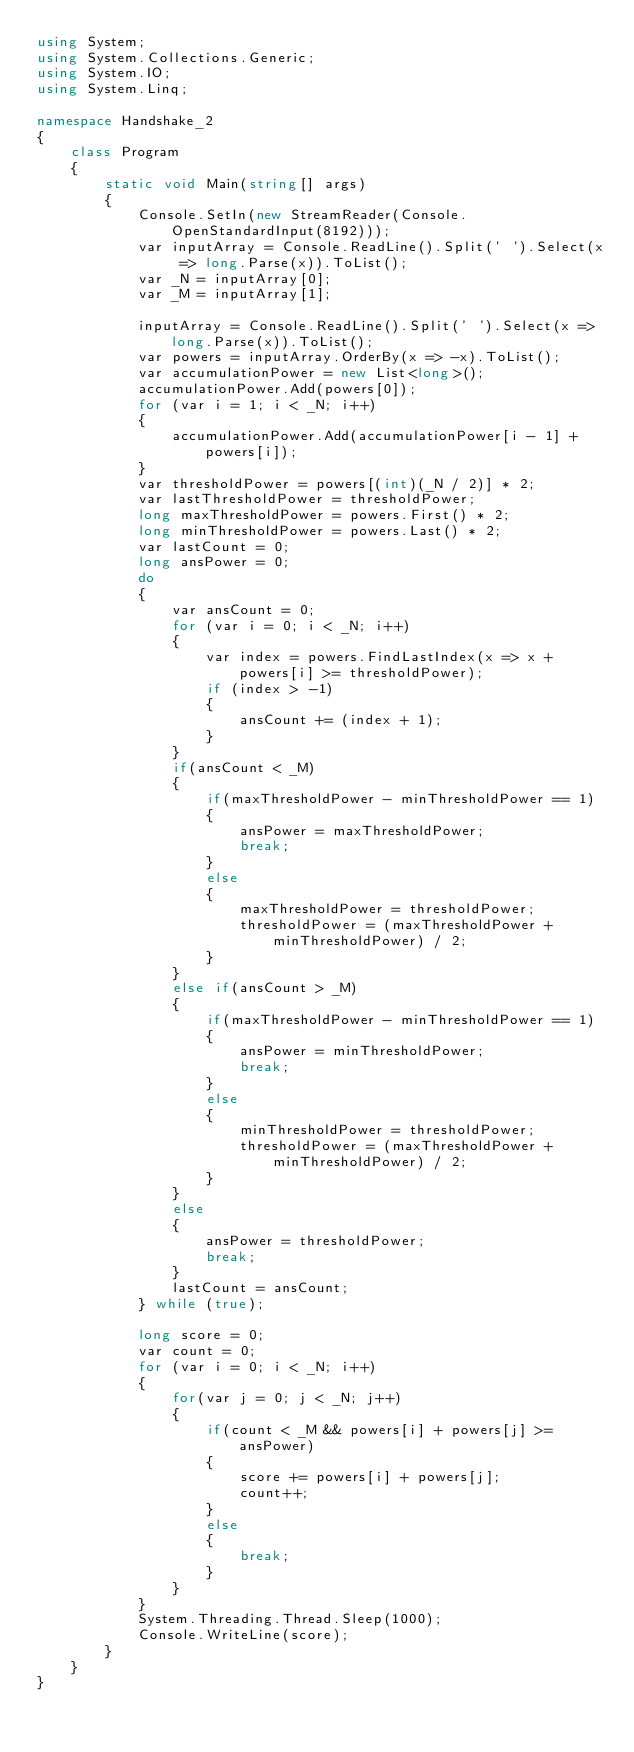Convert code to text. <code><loc_0><loc_0><loc_500><loc_500><_C#_>using System;
using System.Collections.Generic;
using System.IO;
using System.Linq;

namespace Handshake_2
{
    class Program
    {
        static void Main(string[] args)
        {
            Console.SetIn(new StreamReader(Console.OpenStandardInput(8192)));
            var inputArray = Console.ReadLine().Split(' ').Select(x => long.Parse(x)).ToList();
            var _N = inputArray[0];
            var _M = inputArray[1];

            inputArray = Console.ReadLine().Split(' ').Select(x => long.Parse(x)).ToList();
            var powers = inputArray.OrderBy(x => -x).ToList();
            var accumulationPower = new List<long>();
            accumulationPower.Add(powers[0]);
            for (var i = 1; i < _N; i++)
            {
                accumulationPower.Add(accumulationPower[i - 1] + powers[i]);
            }
            var thresholdPower = powers[(int)(_N / 2)] * 2;
            var lastThresholdPower = thresholdPower;
            long maxThresholdPower = powers.First() * 2;
            long minThresholdPower = powers.Last() * 2;
            var lastCount = 0;
            long ansPower = 0;
            do
            {
                var ansCount = 0;
                for (var i = 0; i < _N; i++)
                {
                    var index = powers.FindLastIndex(x => x + powers[i] >= thresholdPower);
                    if (index > -1)
                    {
                        ansCount += (index + 1);
                    }
                }
                if(ansCount < _M)
                {
                    if(maxThresholdPower - minThresholdPower == 1)
                    {
                        ansPower = maxThresholdPower;
                        break;
                    }
                    else
                    {
                        maxThresholdPower = thresholdPower;
                        thresholdPower = (maxThresholdPower + minThresholdPower) / 2;
                    }
                }
                else if(ansCount > _M)
                {
                    if(maxThresholdPower - minThresholdPower == 1)
                    {
                        ansPower = minThresholdPower;
                        break;
                    }
                    else
                    {
                        minThresholdPower = thresholdPower;
                        thresholdPower = (maxThresholdPower + minThresholdPower) / 2;
                    }
                }
                else
                {
                    ansPower = thresholdPower;
                    break;
                }
                lastCount = ansCount;
            } while (true);

            long score = 0;
            var count = 0;
            for (var i = 0; i < _N; i++)
            {
                for(var j = 0; j < _N; j++)
                {
                    if(count < _M && powers[i] + powers[j] >= ansPower)
                    {
                        score += powers[i] + powers[j];
                        count++;
                    }
                    else
                    {
                        break;
                    }
                }
            }
            System.Threading.Thread.Sleep(1000);
            Console.WriteLine(score);
        }
    }
}
</code> 